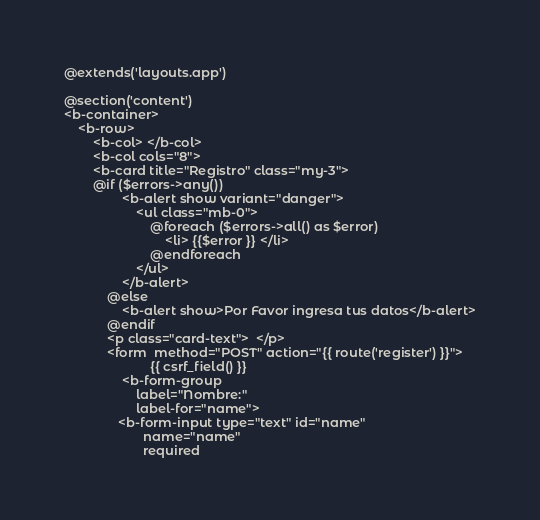<code> <loc_0><loc_0><loc_500><loc_500><_PHP_>@extends('layouts.app')

@section('content')
<b-container>
    <b-row>
        <b-col> </b-col>
        <b-col cols="8">
        <b-card title="Registro" class="my-3">
        @if ($errors->any())
                <b-alert show variant="danger">
                    <ul class="mb-0"> 
                        @foreach ($errors->all() as $error)
                            <li> {{$error }} </li>
                        @endforeach
                    </ul>
                </b-alert>
            @else
                <b-alert show>Por Favor ingresa tus datos</b-alert>
            @endif
            <p class="card-text">  </p>
            <form  method="POST" action="{{ route('register') }}">
                        {{ csrf_field() }}
                <b-form-group 
                    label="Nombre:"
                    label-for="name">
               <b-form-input type="text" id="name"
                      name="name"
                      required</code> 